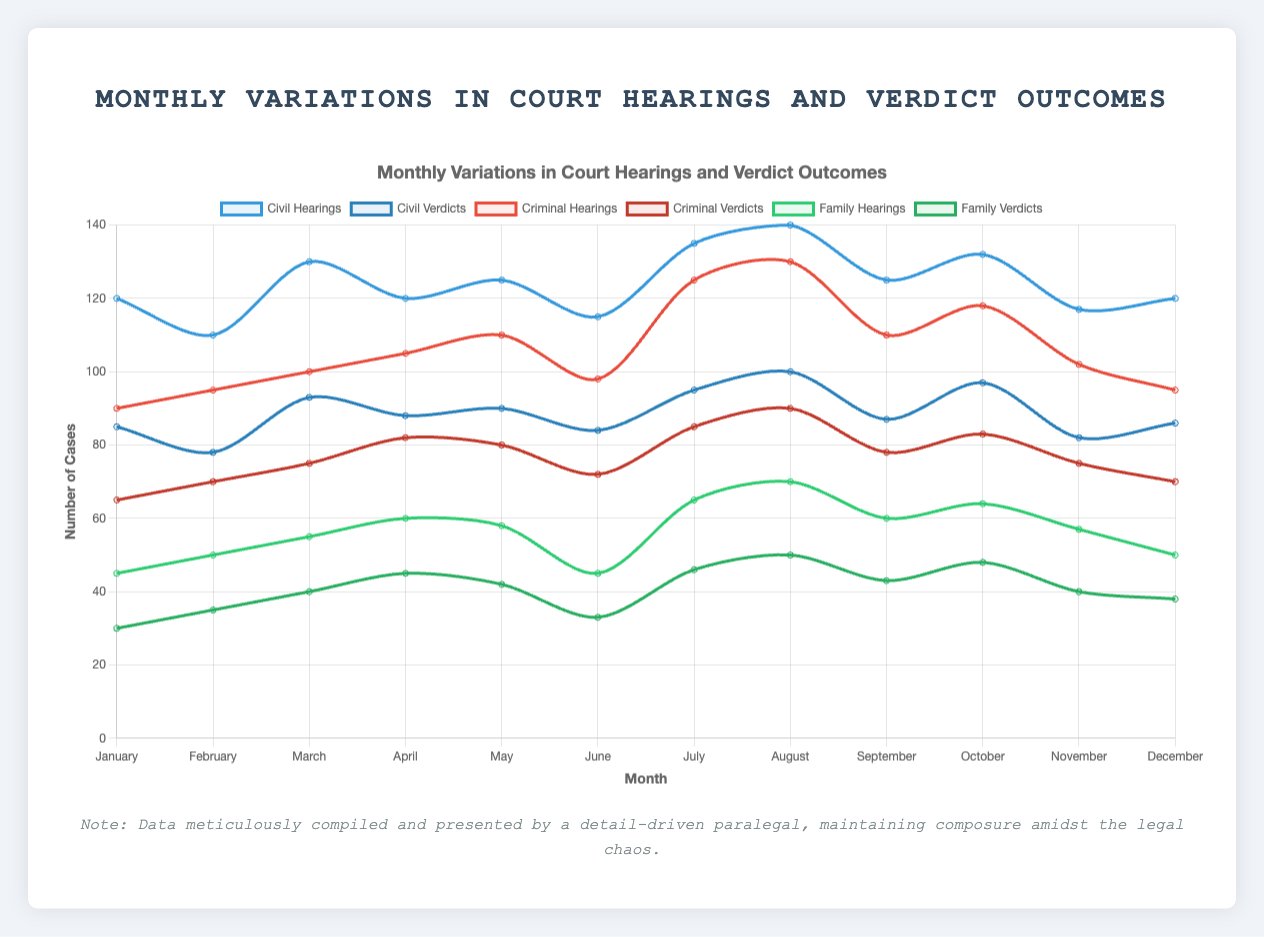What months had the highest and lowest number of civil hearings? By examining the plot for the 'Civil Hearings' line, identify the highest and lowest points along the x-axis (months). The highest is in August and the lowest in February.
Answer: August (highest), February (lowest) During which month do criminal hearings exceed civil hearings? Compare the 'Criminal Hearings' and 'Civil Hearings' lines. Look for the month where the red line (Criminal Hearings) is above the blue line (Civil Hearings). This never happens.
Answer: Never What is the average number of family verdicts in the first and last three months combined? Calculate first three months' total family verdicts (30+35+40 = 105) and last three months' (40+38+43 = 121). Sum them up (105 + 121 = 226) and divide by six months (226/6 ≈ 37.7).
Answer: 37.7 In which month did the number of civil verdicts see the highest increase from the previous month? Calculate the differences in civil verdicts month-by-month and find the maximum increase: February to March (93 - 78 = 15) has the largest increase.
Answer: March Compare the total number of hearings (civil, criminal, family) in July. Add up hearings in each category for July (135+125+65 = 325).
Answer: 325 How many more criminal verdicts were there than family verdicts in September? Subtract family verdicts from criminal verdicts in September (78 - 43 = 35).
Answer: 35 Which month had the closest number of civil and criminal verdicts? Look at the differences between civil and criminal verdicts in each month and identify the smallest difference. July had 95 (Civil) vs. 85 (Criminal), a difference of 10.
Answer: July Which category and month had the steepest drop in hearings compared to the previous month? Calculate month-to-month drops for each category (Civil, Criminal, Family). The steepest drop: Family Hearings from August to September went from 70 to 60, a drop of 10.
Answer: Family Hearings, September What is the total number of criminal hearings in the first half of the year? Sum the number of criminal hearings from January to June (90 + 95 + 100 + 105 + 110 + 98 = 598).
Answer: 598 